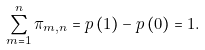<formula> <loc_0><loc_0><loc_500><loc_500>\sum _ { m = 1 } ^ { n } \pi _ { m , n } = p \left ( 1 \right ) - p \left ( 0 \right ) = 1 .</formula> 